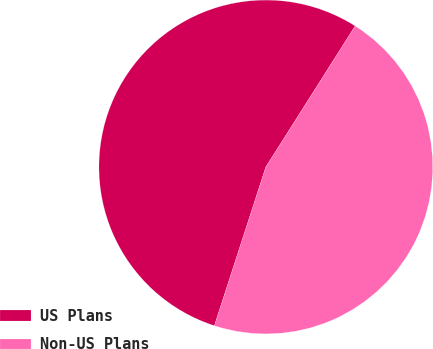Convert chart. <chart><loc_0><loc_0><loc_500><loc_500><pie_chart><fcel>US Plans<fcel>Non-US Plans<nl><fcel>54.0%<fcel>46.0%<nl></chart> 